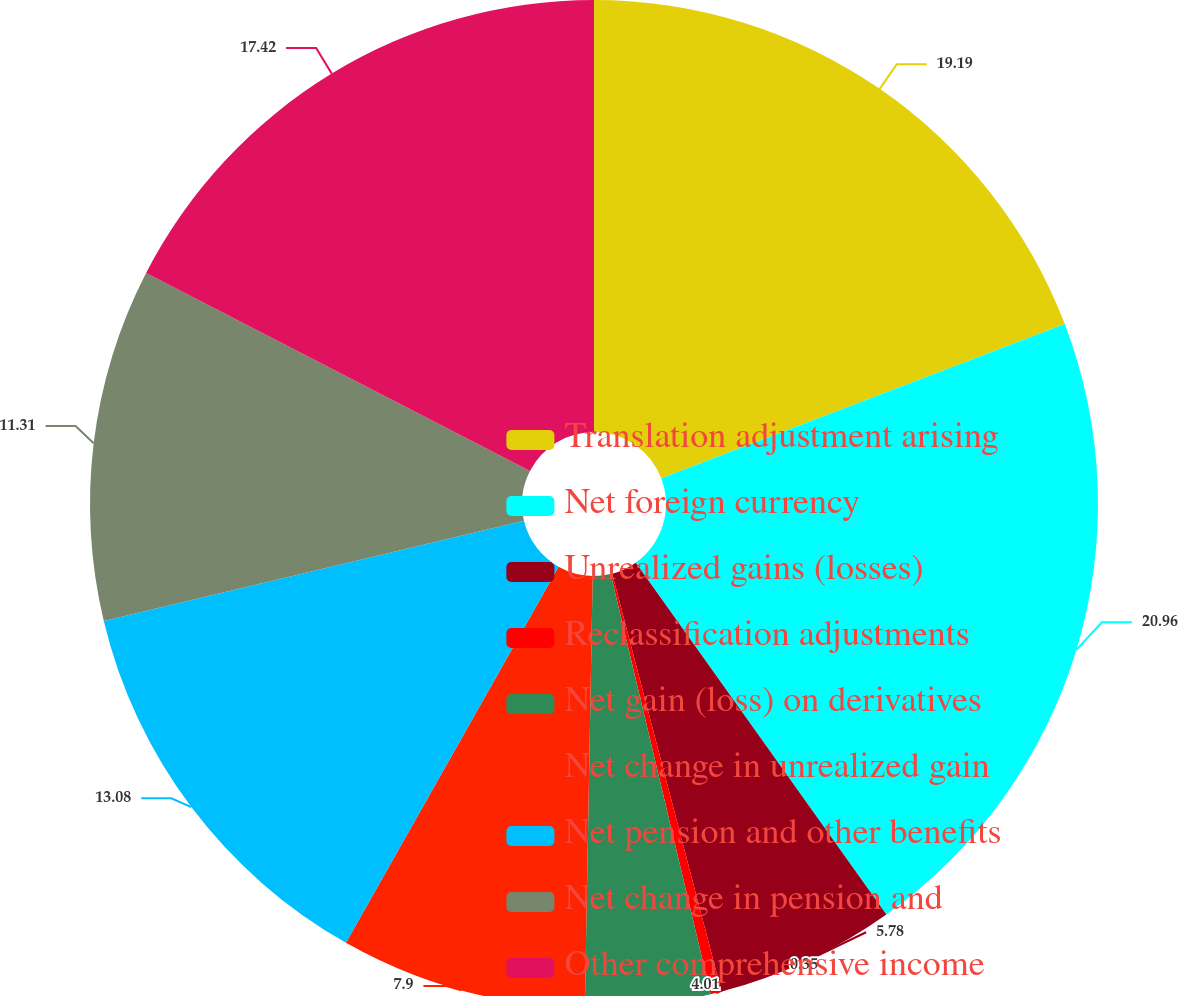Convert chart to OTSL. <chart><loc_0><loc_0><loc_500><loc_500><pie_chart><fcel>Translation adjustment arising<fcel>Net foreign currency<fcel>Unrealized gains (losses)<fcel>Reclassification adjustments<fcel>Net gain (loss) on derivatives<fcel>Net change in unrealized gain<fcel>Net pension and other benefits<fcel>Net change in pension and<fcel>Other comprehensive income<nl><fcel>19.19%<fcel>20.96%<fcel>5.78%<fcel>0.35%<fcel>4.01%<fcel>7.9%<fcel>13.08%<fcel>11.31%<fcel>17.42%<nl></chart> 